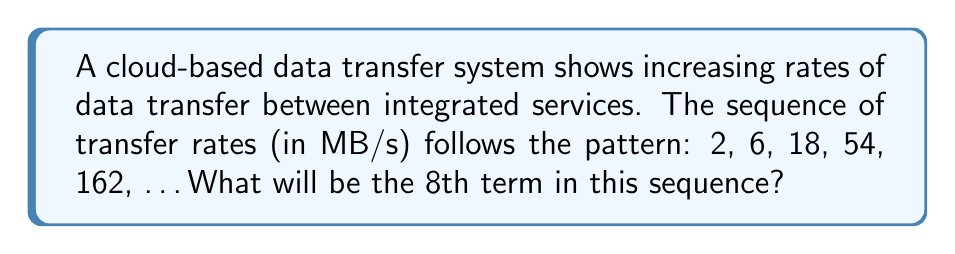Help me with this question. To solve this problem, let's analyze the pattern in the given sequence:

1) First, identify the relationship between consecutive terms:
   $\frac{6}{2} = 3$, $\frac{18}{6} = 3$, $\frac{54}{18} = 3$, $\frac{162}{54} = 3$

2) We can see that each term is 3 times the previous term. This is a geometric sequence with a common ratio of 3.

3) The general formula for a geometric sequence is:
   $a_n = a_1 \cdot r^{n-1}$
   Where $a_n$ is the nth term, $a_1$ is the first term, r is the common ratio, and n is the position of the term.

4) In this case:
   $a_1 = 2$ (first term)
   $r = 3$ (common ratio)
   We need to find $a_8$ (8th term)

5) Substituting into the formula:
   $a_8 = 2 \cdot 3^{8-1} = 2 \cdot 3^7$

6) Calculate:
   $a_8 = 2 \cdot 3^7 = 2 \cdot 2187 = 4374$

Therefore, the 8th term in the sequence will be 4374 MB/s.
Answer: 4374 MB/s 